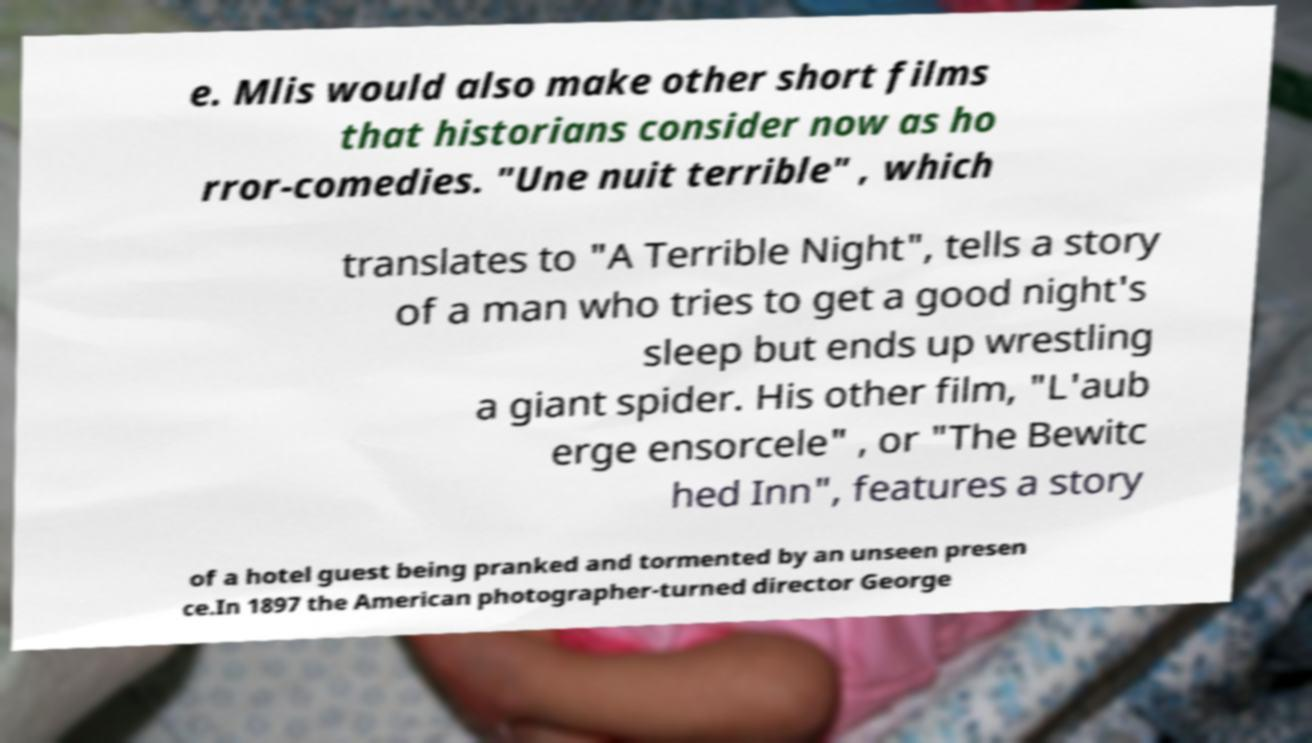For documentation purposes, I need the text within this image transcribed. Could you provide that? e. Mlis would also make other short films that historians consider now as ho rror-comedies. "Une nuit terrible" , which translates to "A Terrible Night", tells a story of a man who tries to get a good night's sleep but ends up wrestling a giant spider. His other film, "L'aub erge ensorcele" , or "The Bewitc hed Inn", features a story of a hotel guest being pranked and tormented by an unseen presen ce.In 1897 the American photographer-turned director George 